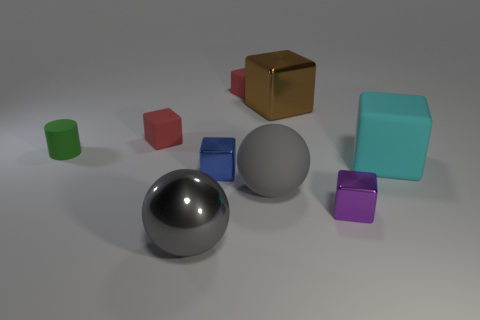Subtract 2 blocks. How many blocks are left? 4 Subtract all blue blocks. How many blocks are left? 5 Subtract all brown blocks. How many blocks are left? 5 Subtract all green blocks. Subtract all blue spheres. How many blocks are left? 6 Add 1 red metal cylinders. How many objects exist? 10 Subtract all spheres. How many objects are left? 7 Subtract all gray balls. Subtract all blue balls. How many objects are left? 7 Add 8 gray things. How many gray things are left? 10 Add 5 cylinders. How many cylinders exist? 6 Subtract 0 blue spheres. How many objects are left? 9 